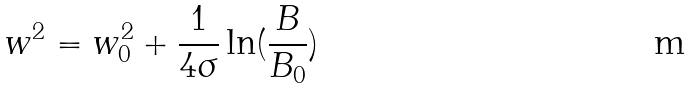Convert formula to latex. <formula><loc_0><loc_0><loc_500><loc_500>w ^ { 2 } = w _ { 0 } ^ { 2 } + \frac { 1 } { 4 \sigma } \ln ( \frac { B } { B _ { 0 } } )</formula> 